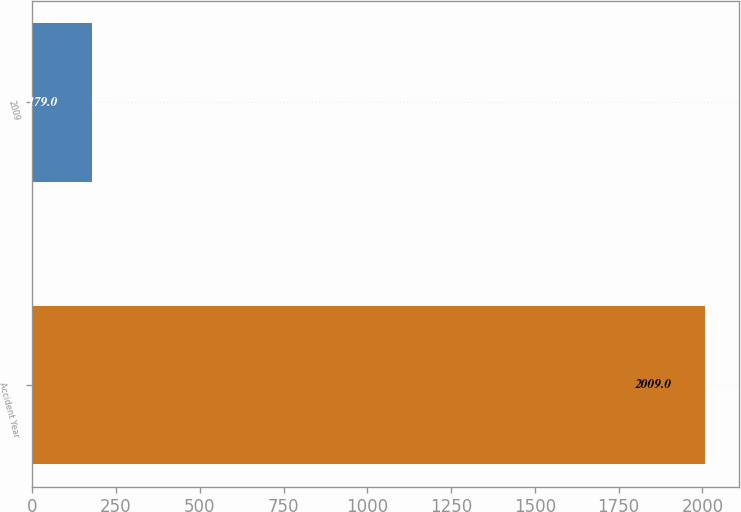Convert chart to OTSL. <chart><loc_0><loc_0><loc_500><loc_500><bar_chart><fcel>Accident Year<fcel>2009<nl><fcel>2009<fcel>179<nl></chart> 